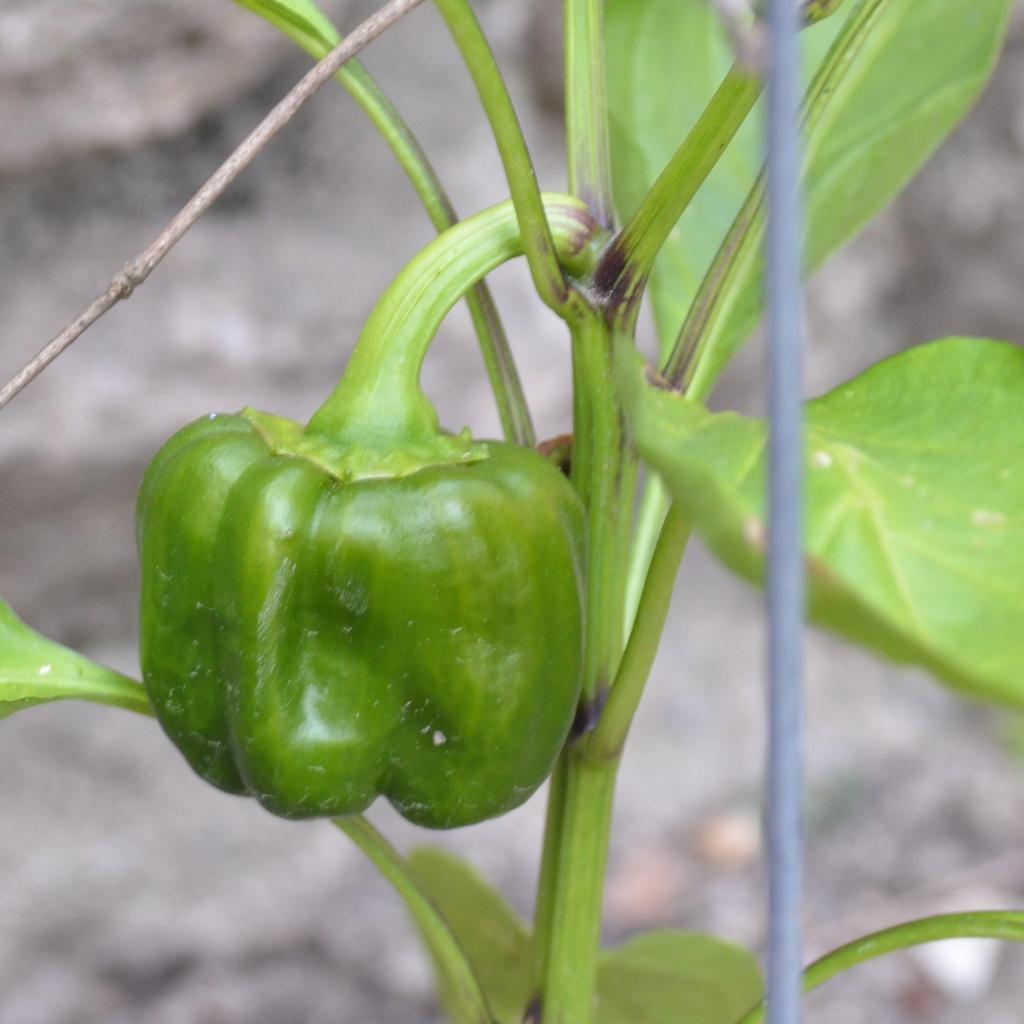How would you summarize this image in a sentence or two? As we can see in the image there is plant and capsicum vegetable. The background is blurred. 